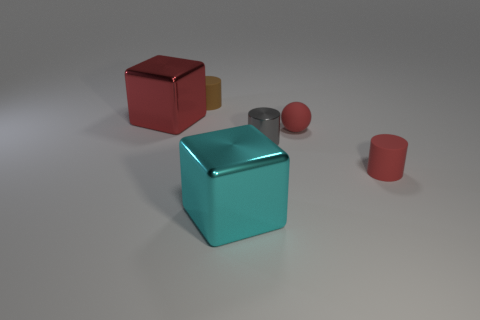What is the shape of the cyan metallic thing that is the same size as the red metal block?
Provide a succinct answer. Cube. There is a big thing that is the same color as the rubber ball; what is its shape?
Your answer should be very brief. Cube. Are there more small rubber things in front of the big red cube than cyan metal objects?
Your response must be concise. Yes. There is a gray cylinder; how many large cyan metallic objects are to the right of it?
Your answer should be compact. 0. Is there a red matte cylinder of the same size as the brown object?
Your answer should be compact. Yes. There is another shiny object that is the same shape as the large cyan metallic object; what is its color?
Provide a short and direct response. Red. Does the matte object that is to the left of the large cyan shiny object have the same size as the object that is to the right of the red matte sphere?
Keep it short and to the point. Yes. Are there any other red objects of the same shape as the small metallic thing?
Make the answer very short. Yes. Are there an equal number of red metal objects that are to the right of the small gray shiny thing and tiny spheres?
Offer a terse response. No. Do the gray thing and the rubber cylinder that is behind the big red shiny cube have the same size?
Ensure brevity in your answer.  Yes. 